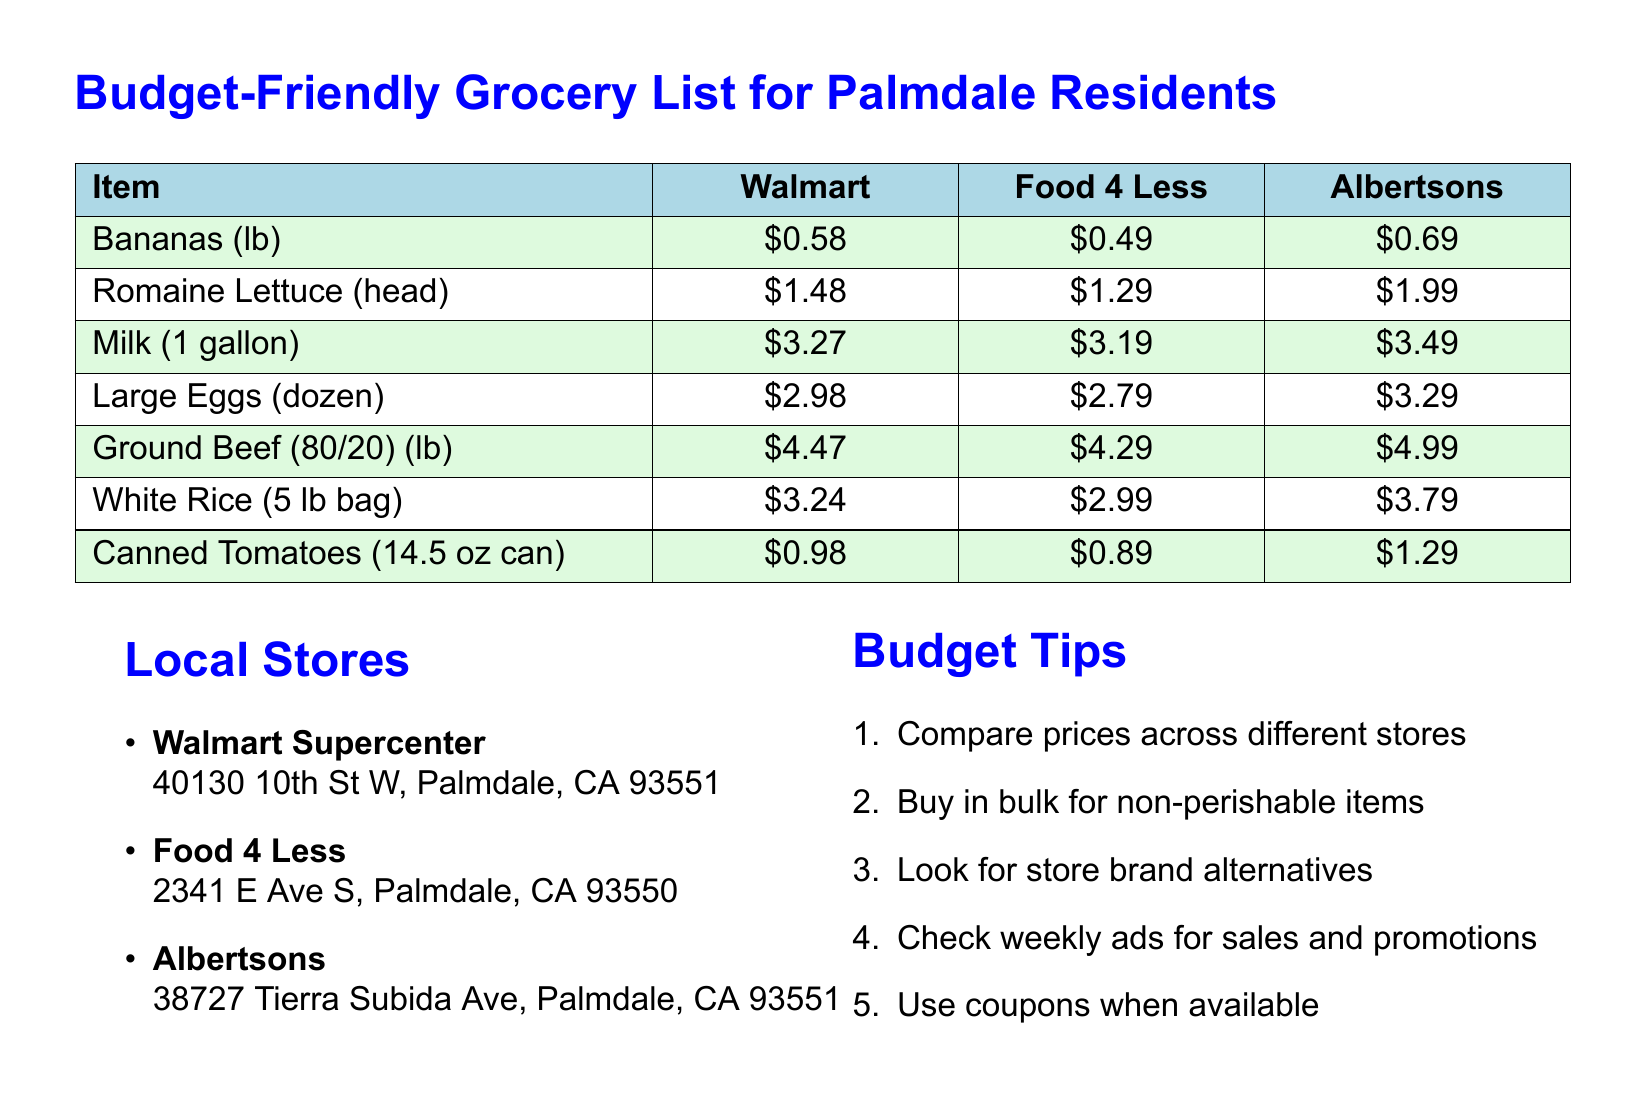What is the price of romaine lettuce at Walmart? The price of romaine lettuce at Walmart is listed in the document.
Answer: $1.48 Which store has the cheapest canned tomatoes? The document provides the prices across different stores, and Food 4 Less has the lowest price for canned tomatoes.
Answer: $0.89 How much does a gallon of milk cost at Albertsons? The price of milk at Albertsons is stated in the table within the document.
Answer: $3.49 Which store offers the lowest price for large eggs? The document lists prices for large eggs at three stores and Food 4 Less offers the lowest price.
Answer: $2.79 What is a budget tip mentioned in the document? The document contains a list of budget tips for grocery shopping.
Answer: Compare prices across different stores How much is a 5 lb bag of white rice at Food 4 Less? The document provides specific prices for each item at Food 4 Less, and this can be found in the table.
Answer: $2.99 Which local store is located at 40130 10th St W? The document mentions local stores along with their addresses, identifying Walmart as the one at this address.
Answer: Walmart Supercenter What is the price difference of ground beef between Walmart and Albertsons? The price of ground beef at Walmart and Albertsons is given in the table, and the difference needs to be calculated.
Answer: $0.52 